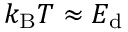<formula> <loc_0><loc_0><loc_500><loc_500>k _ { B } T \approx E _ { d }</formula> 